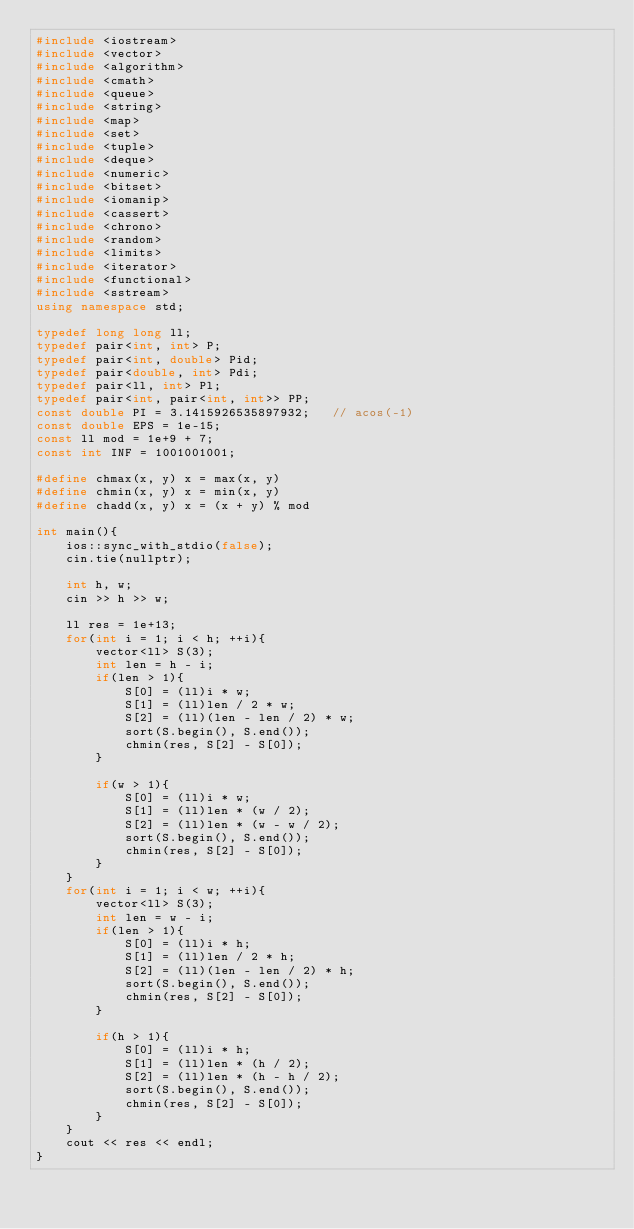Convert code to text. <code><loc_0><loc_0><loc_500><loc_500><_C++_>#include <iostream>
#include <vector>
#include <algorithm>
#include <cmath>
#include <queue>
#include <string>
#include <map>
#include <set>
#include <tuple>
#include <deque>
#include <numeric>
#include <bitset>
#include <iomanip>
#include <cassert>
#include <chrono>
#include <random>
#include <limits>
#include <iterator>
#include <functional>
#include <sstream>
using namespace std;

typedef long long ll;
typedef pair<int, int> P;
typedef pair<int, double> Pid;
typedef pair<double, int> Pdi;
typedef pair<ll, int> Pl;
typedef pair<int, pair<int, int>> PP;
const double PI = 3.1415926535897932;   // acos(-1)
const double EPS = 1e-15;
const ll mod = 1e+9 + 7;
const int INF = 1001001001;

#define chmax(x, y) x = max(x, y)
#define chmin(x, y) x = min(x, y)
#define chadd(x, y) x = (x + y) % mod

int main(){
    ios::sync_with_stdio(false);
    cin.tie(nullptr);

    int h, w;
    cin >> h >> w;

    ll res = 1e+13;
    for(int i = 1; i < h; ++i){
        vector<ll> S(3);
        int len = h - i;
        if(len > 1){
            S[0] = (ll)i * w;
            S[1] = (ll)len / 2 * w;
            S[2] = (ll)(len - len / 2) * w;
            sort(S.begin(), S.end());
            chmin(res, S[2] - S[0]);
        }

        if(w > 1){
            S[0] = (ll)i * w;
            S[1] = (ll)len * (w / 2);
            S[2] = (ll)len * (w - w / 2);
            sort(S.begin(), S.end());
            chmin(res, S[2] - S[0]);
        }
    }
    for(int i = 1; i < w; ++i){
        vector<ll> S(3);
        int len = w - i;
        if(len > 1){
            S[0] = (ll)i * h;
            S[1] = (ll)len / 2 * h;
            S[2] = (ll)(len - len / 2) * h;
            sort(S.begin(), S.end());
            chmin(res, S[2] - S[0]);
        }

        if(h > 1){
            S[0] = (ll)i * h;
            S[1] = (ll)len * (h / 2);
            S[2] = (ll)len * (h - h / 2);
            sort(S.begin(), S.end());
            chmin(res, S[2] - S[0]);
        }
    }
    cout << res << endl;
}</code> 